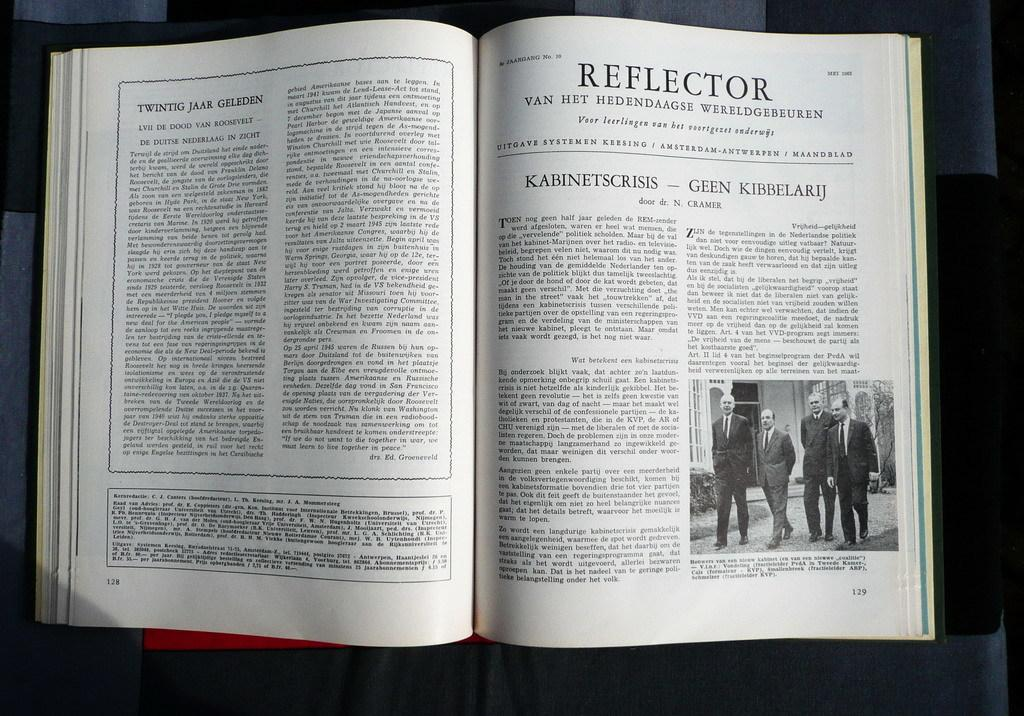<image>
Write a terse but informative summary of the picture. Book open on a page titled "Reflector" showing four men walking. 